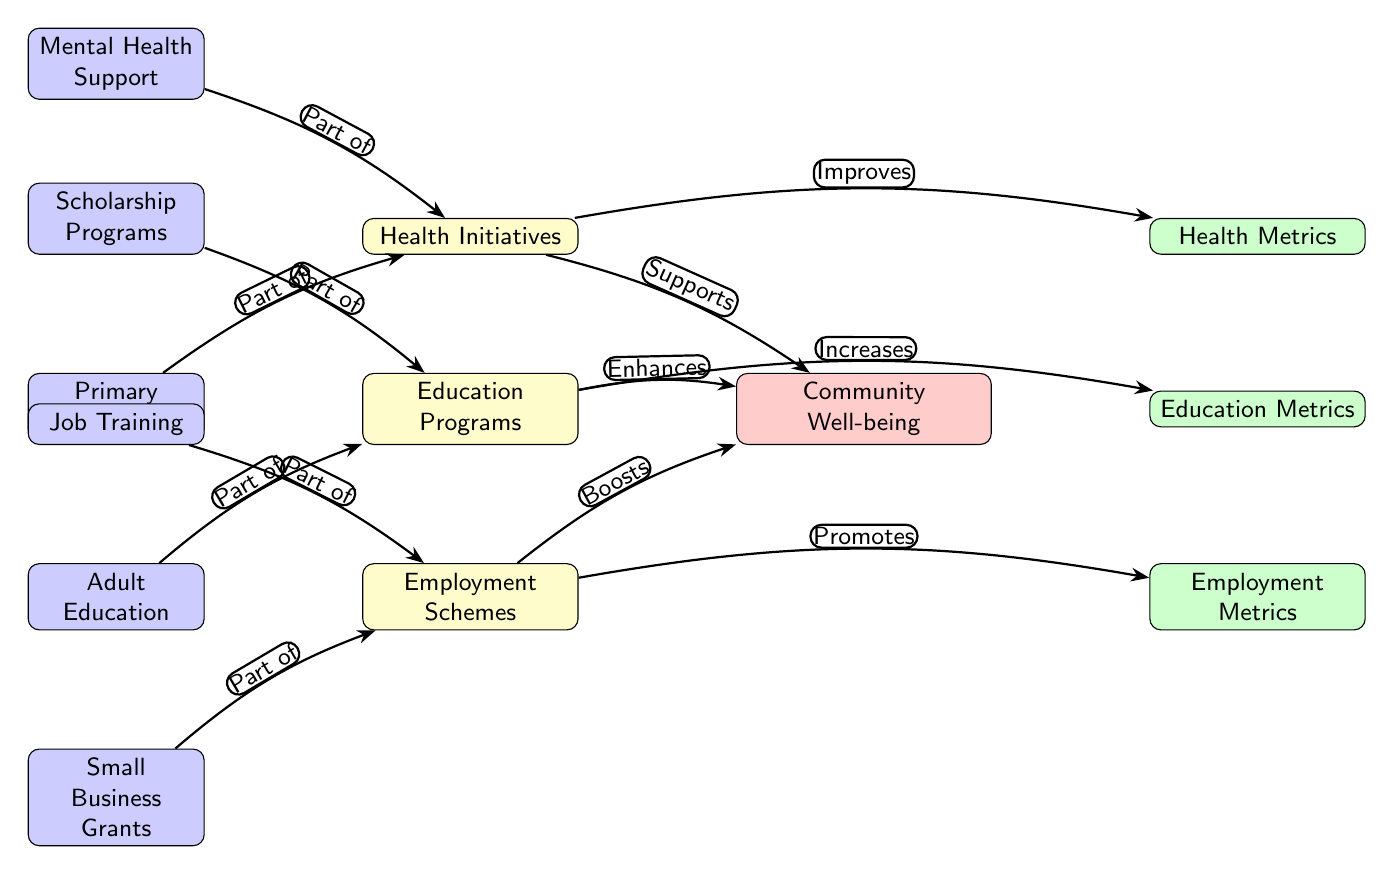What are the three main initiatives depicted in the diagram? The diagram shows three main initiatives: Health Initiatives, Education Programs, and Employment Schemes, which are positioned as direct contributors to community well-being.
Answer: Health Initiatives, Education Programs, Employment Schemes How many metrics are linked to the community well-being in the diagram? The diagram has three metrics connected to the community well-being: Health Metrics, Education Metrics, and Employment Metrics, indicated by the metrics' nodes.
Answer: Three What kind of support does Mental Health Support provide? The diagram shows that Mental Health Support is part of the Health Initiatives, contributing by supporting community well-being through mental health resources.
Answer: Supports Which initiative enhances education metrics according to the diagram? The Education Programs initiative enhances the education metrics as indicated by the edge labeled "Enhances" pointing from Education Programs to Education Metrics.
Answer: Education Programs What type of program is Job Training classified under? Job Training is classified as part of the Employment Schemes initiative, as shown by its placement and connection in the diagram.
Answer: Employment Schemes What relationship is indicated between Primary Healthcare and community well-being? The diagram indicates that Primary Healthcare improves community well-being through the edge labeled "Improves" connecting it to Health Metrics and then linking to Community Well-being.
Answer: Improves Which metric does Employment Schemes promote? The Employment Schemes initiative promotes Employment Metrics, as indicated by the edge labeled "Promotes" directed toward Employment Metrics from Employment Schemes.
Answer: Employment Metrics What does the arrow labeled "Part of" signify in this diagram? The arrows labeled "Part of" signify that the specific programs (like Mental Health Support) are components or subsets of the broader initiatives (like Health Initiatives) in the diagram.
Answer: Part of How does the diagram depict the contribution of Scholarship Programs? The Scholarship Programs, as part of the Education Programs initiative, contribute positively to community well-being by enhancing Education Metrics, reflected in the edges connecting them in the diagram.
Answer: Enhances 